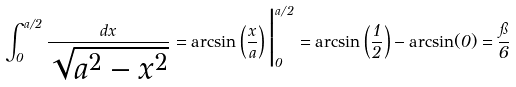Convert formula to latex. <formula><loc_0><loc_0><loc_500><loc_500>\int _ { 0 } ^ { a / 2 } { \frac { d x } { \sqrt { a ^ { 2 } - x ^ { 2 } } } } = \arcsin \left ( { \frac { x } { a } } \right ) { \Big | } _ { 0 } ^ { a / 2 } = \arcsin \left ( { \frac { 1 } { 2 } } \right ) - \arcsin ( 0 ) = { \frac { \pi } { 6 } }</formula> 